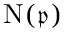<formula> <loc_0><loc_0><loc_500><loc_500>{ N } ( { \mathfrak { p } } )</formula> 